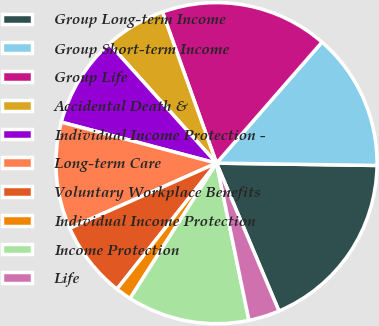Convert chart. <chart><loc_0><loc_0><loc_500><loc_500><pie_chart><fcel>Group Long-term Income<fcel>Group Short-term Income<fcel>Group Life<fcel>Accidental Death &<fcel>Individual Income Protection -<fcel>Long-term Care<fcel>Voluntary Workplace Benefits<fcel>Individual Income Protection<fcel>Income Protection<fcel>Life<nl><fcel>18.41%<fcel>13.82%<fcel>16.88%<fcel>6.18%<fcel>9.24%<fcel>10.76%<fcel>7.71%<fcel>1.59%<fcel>12.29%<fcel>3.12%<nl></chart> 